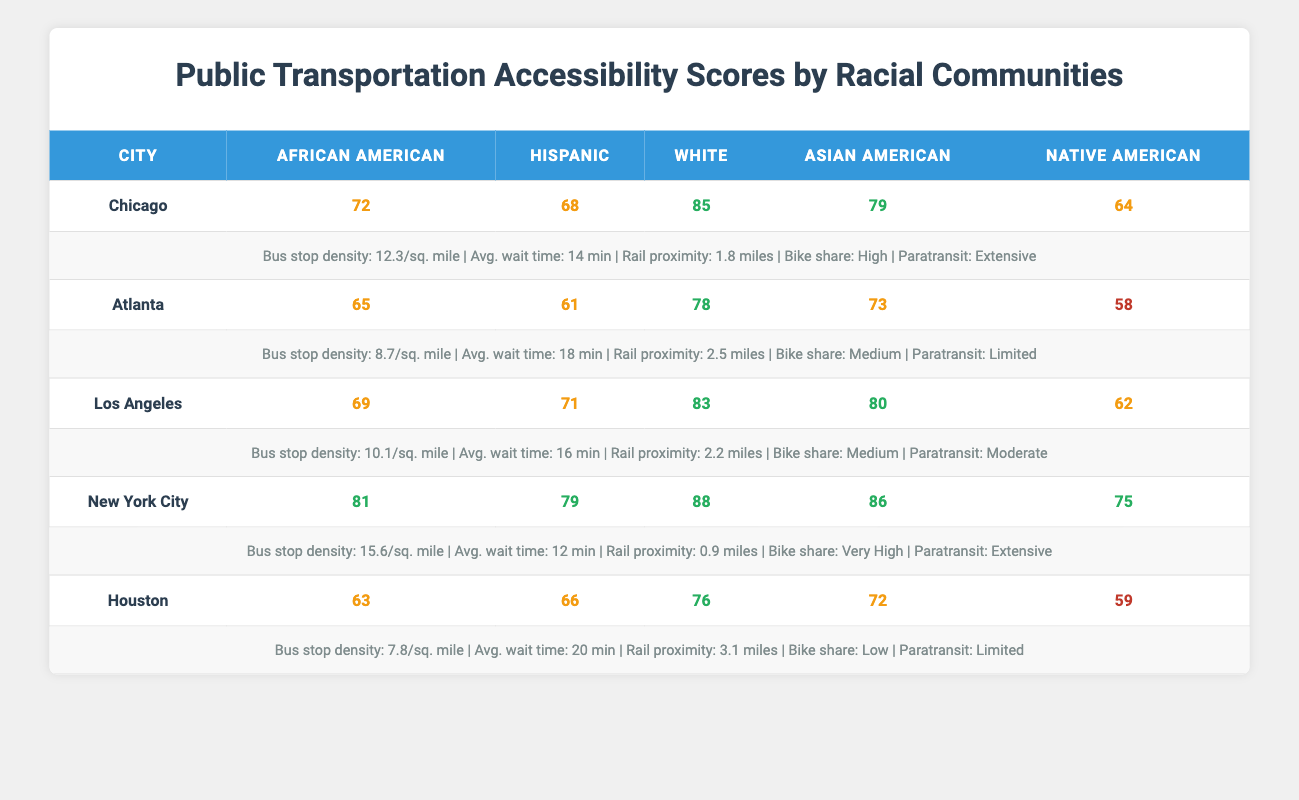What is the highest public transportation accessibility score for African American communities across the cities listed? By looking at the African American scores in the table, we find the scores: Chicago (72), Atlanta (65), Los Angeles (69), New York City (81), and Houston (63). The highest score is in New York City at 81.
Answer: 81 Which city has the lowest public transportation accessibility score for Hispanic communities? The Hispanic scores in the table are: Chicago (68), Atlanta (61), Los Angeles (71), New York City (79), and Houston (66). The lowest score is in Atlanta at 61.
Answer: 61 What is the average public transportation accessibility score for White communities across all cities? The White scores are: Chicago (85), Atlanta (78), Los Angeles (83), New York City (88), and Houston (76). Summing these gives 85 + 78 + 83 + 88 + 76 = 410. There are 5 values, so the average is 410 / 5 = 82.
Answer: 82 Is it true that Asian American communities in New York City have a higher accessibility score than Hispanic communities in Chicago? The Asian American score in New York City is 86, and the Hispanic score in Chicago is 68. Since 86 is greater than 68, the statement is true.
Answer: Yes Which city has the highest accessibility score for Native American communities? The Native American scores are: Chicago (64), Atlanta (58), Los Angeles (62), New York City (75), and Houston (59). The highest score is in New York City at 75.
Answer: 75 What is the difference in public transportation accessibility scores between African American and White communities in Atlanta? In Atlanta, the African American score is 65 and the White score is 78. The difference is calculated by subtracting the African American score from the White score: 78 - 65 = 13.
Answer: 13 Are the public transportation accessibility scores for the Asian American community higher in Los Angeles or Houston? The Asian American score in Los Angeles is 80, while in Houston it is 72. Since 80 is greater than 72, the score in Los Angeles is higher.
Answer: Los Angeles What city has the best public transportation accessibility scores for all communities? By reviewing the table, we can analyze the scores: New York City (81, 79, 88, 86, 75) has the highest scores across the board, consistently above the others. No other city has all scores near this high.
Answer: New York City What is the bus stop density for Houston and how does it compare to that of Chicago? The bus stop density for Houston is 7.8 per square mile, while for Chicago, it is 12.3 per square mile. Hence, Houston's density is lower than Chicago's.
Answer: Lower than Chicago 